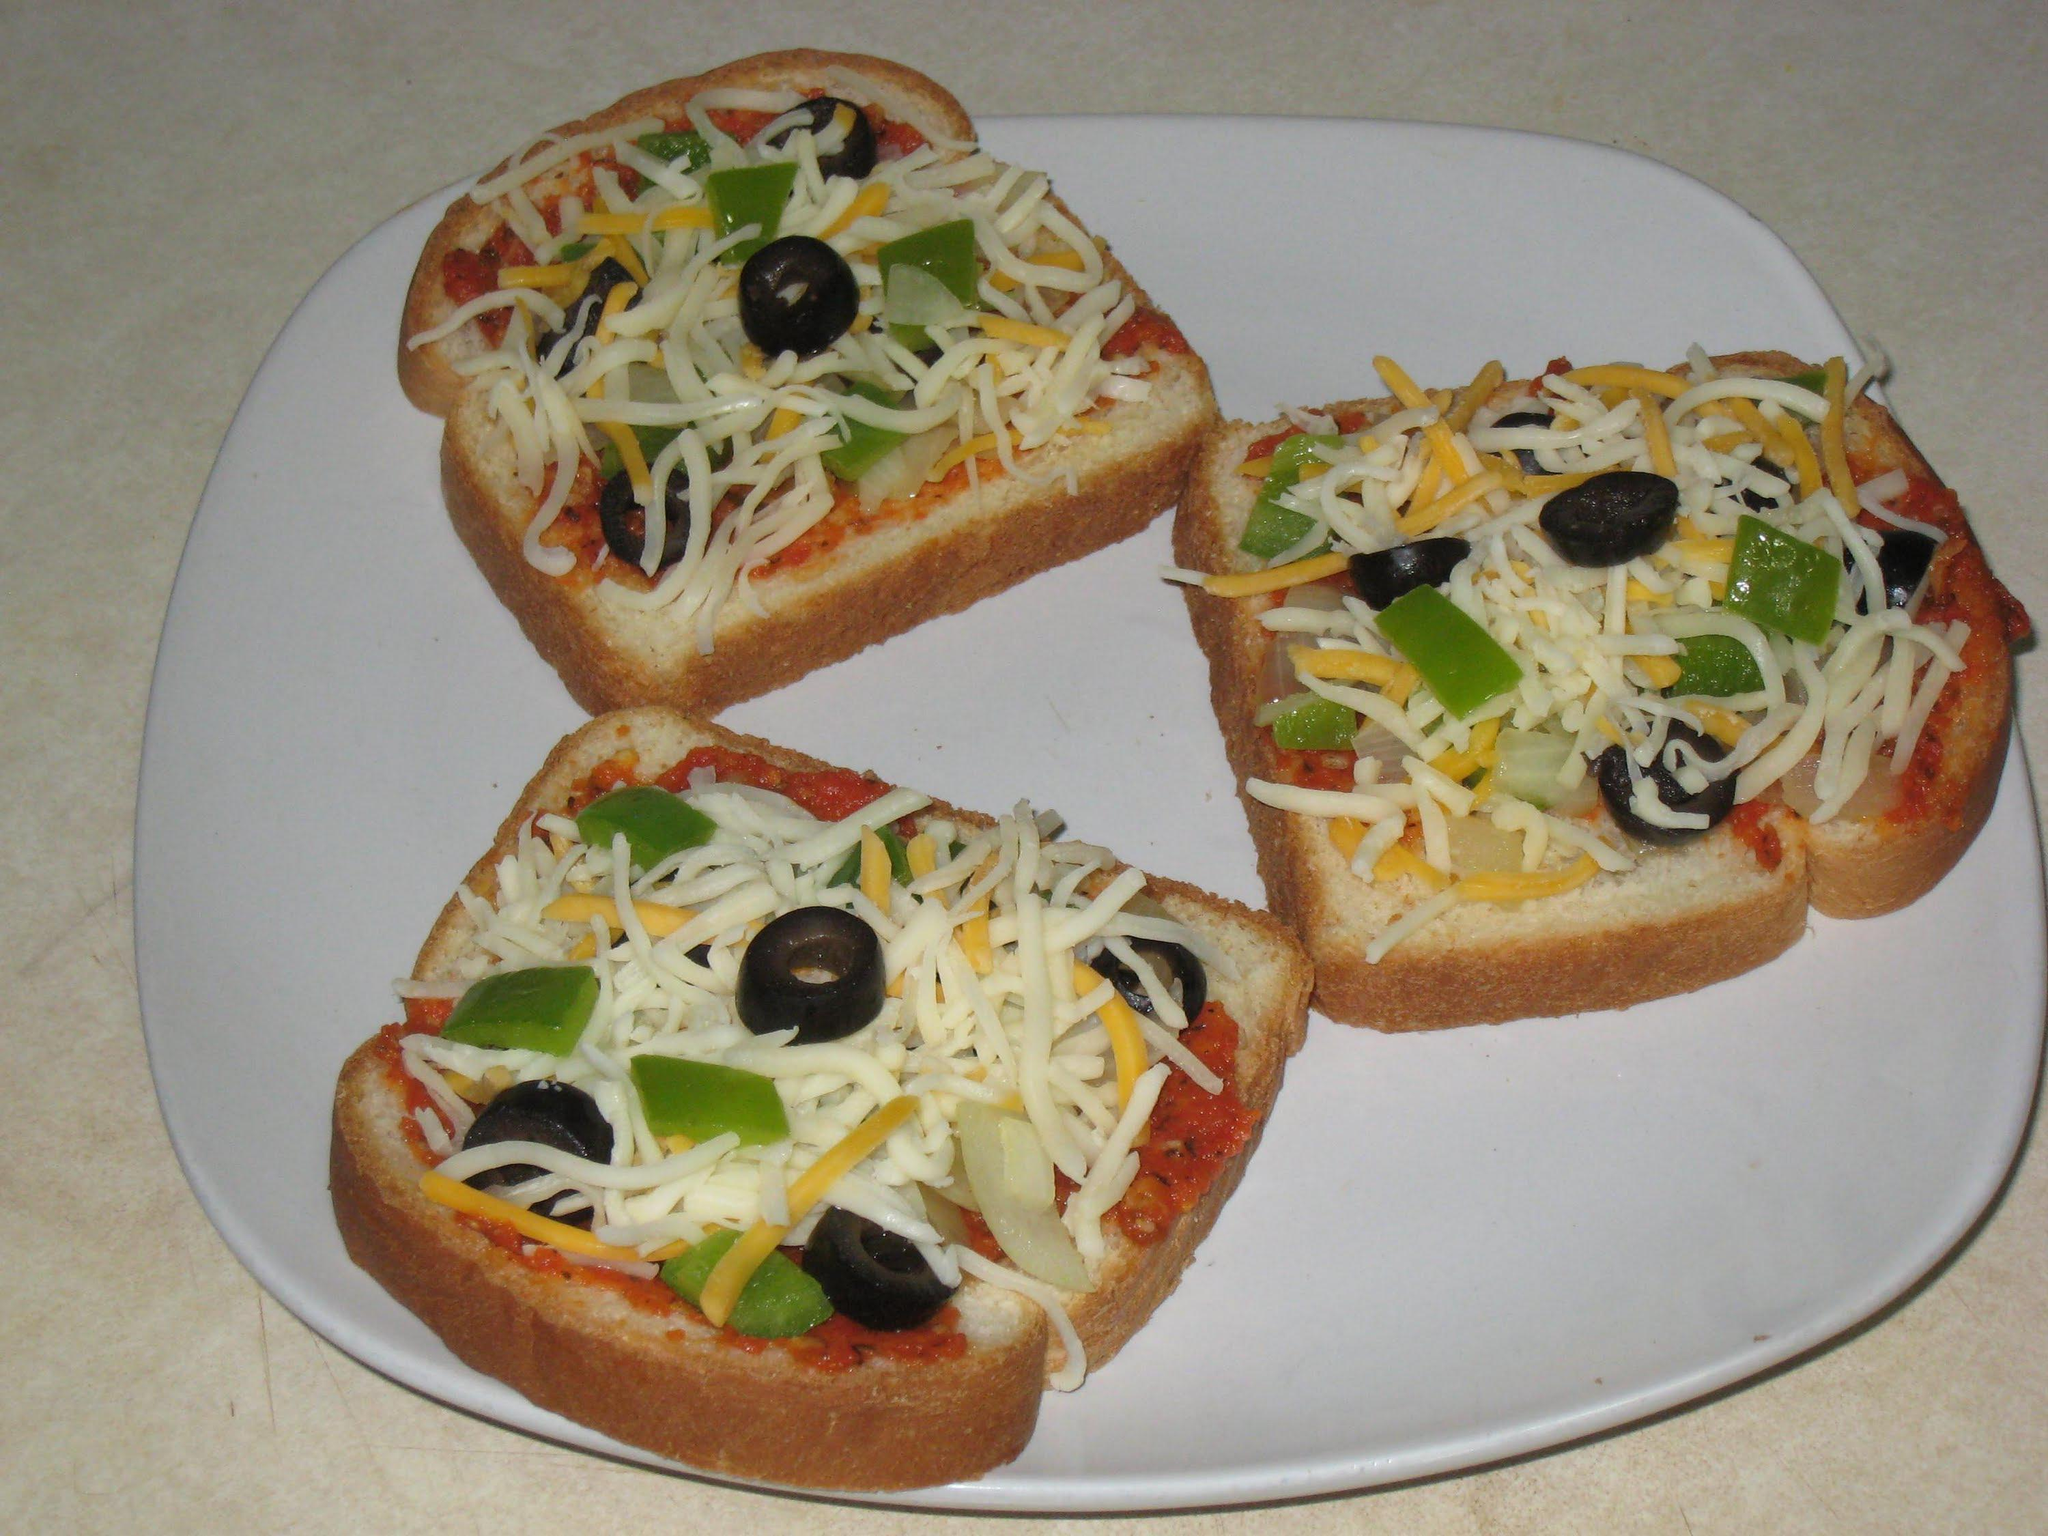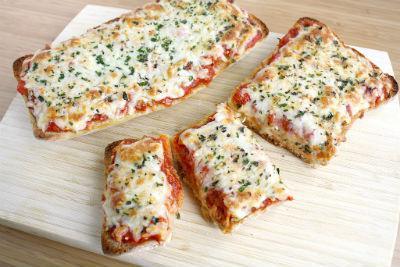The first image is the image on the left, the second image is the image on the right. Considering the images on both sides, is "In one image, four pieces of french bread pizza are covered with cheese, while a second image shows pizza made with slices of bread used for the crust." valid? Answer yes or no. Yes. The first image is the image on the left, the second image is the image on the right. Assess this claim about the two images: "One image shows four rectangles covered in red sauce, melted cheese, and green herbs on a wooden board, and the other image includes a topped slice of bread on a white plate.". Correct or not? Answer yes or no. Yes. 